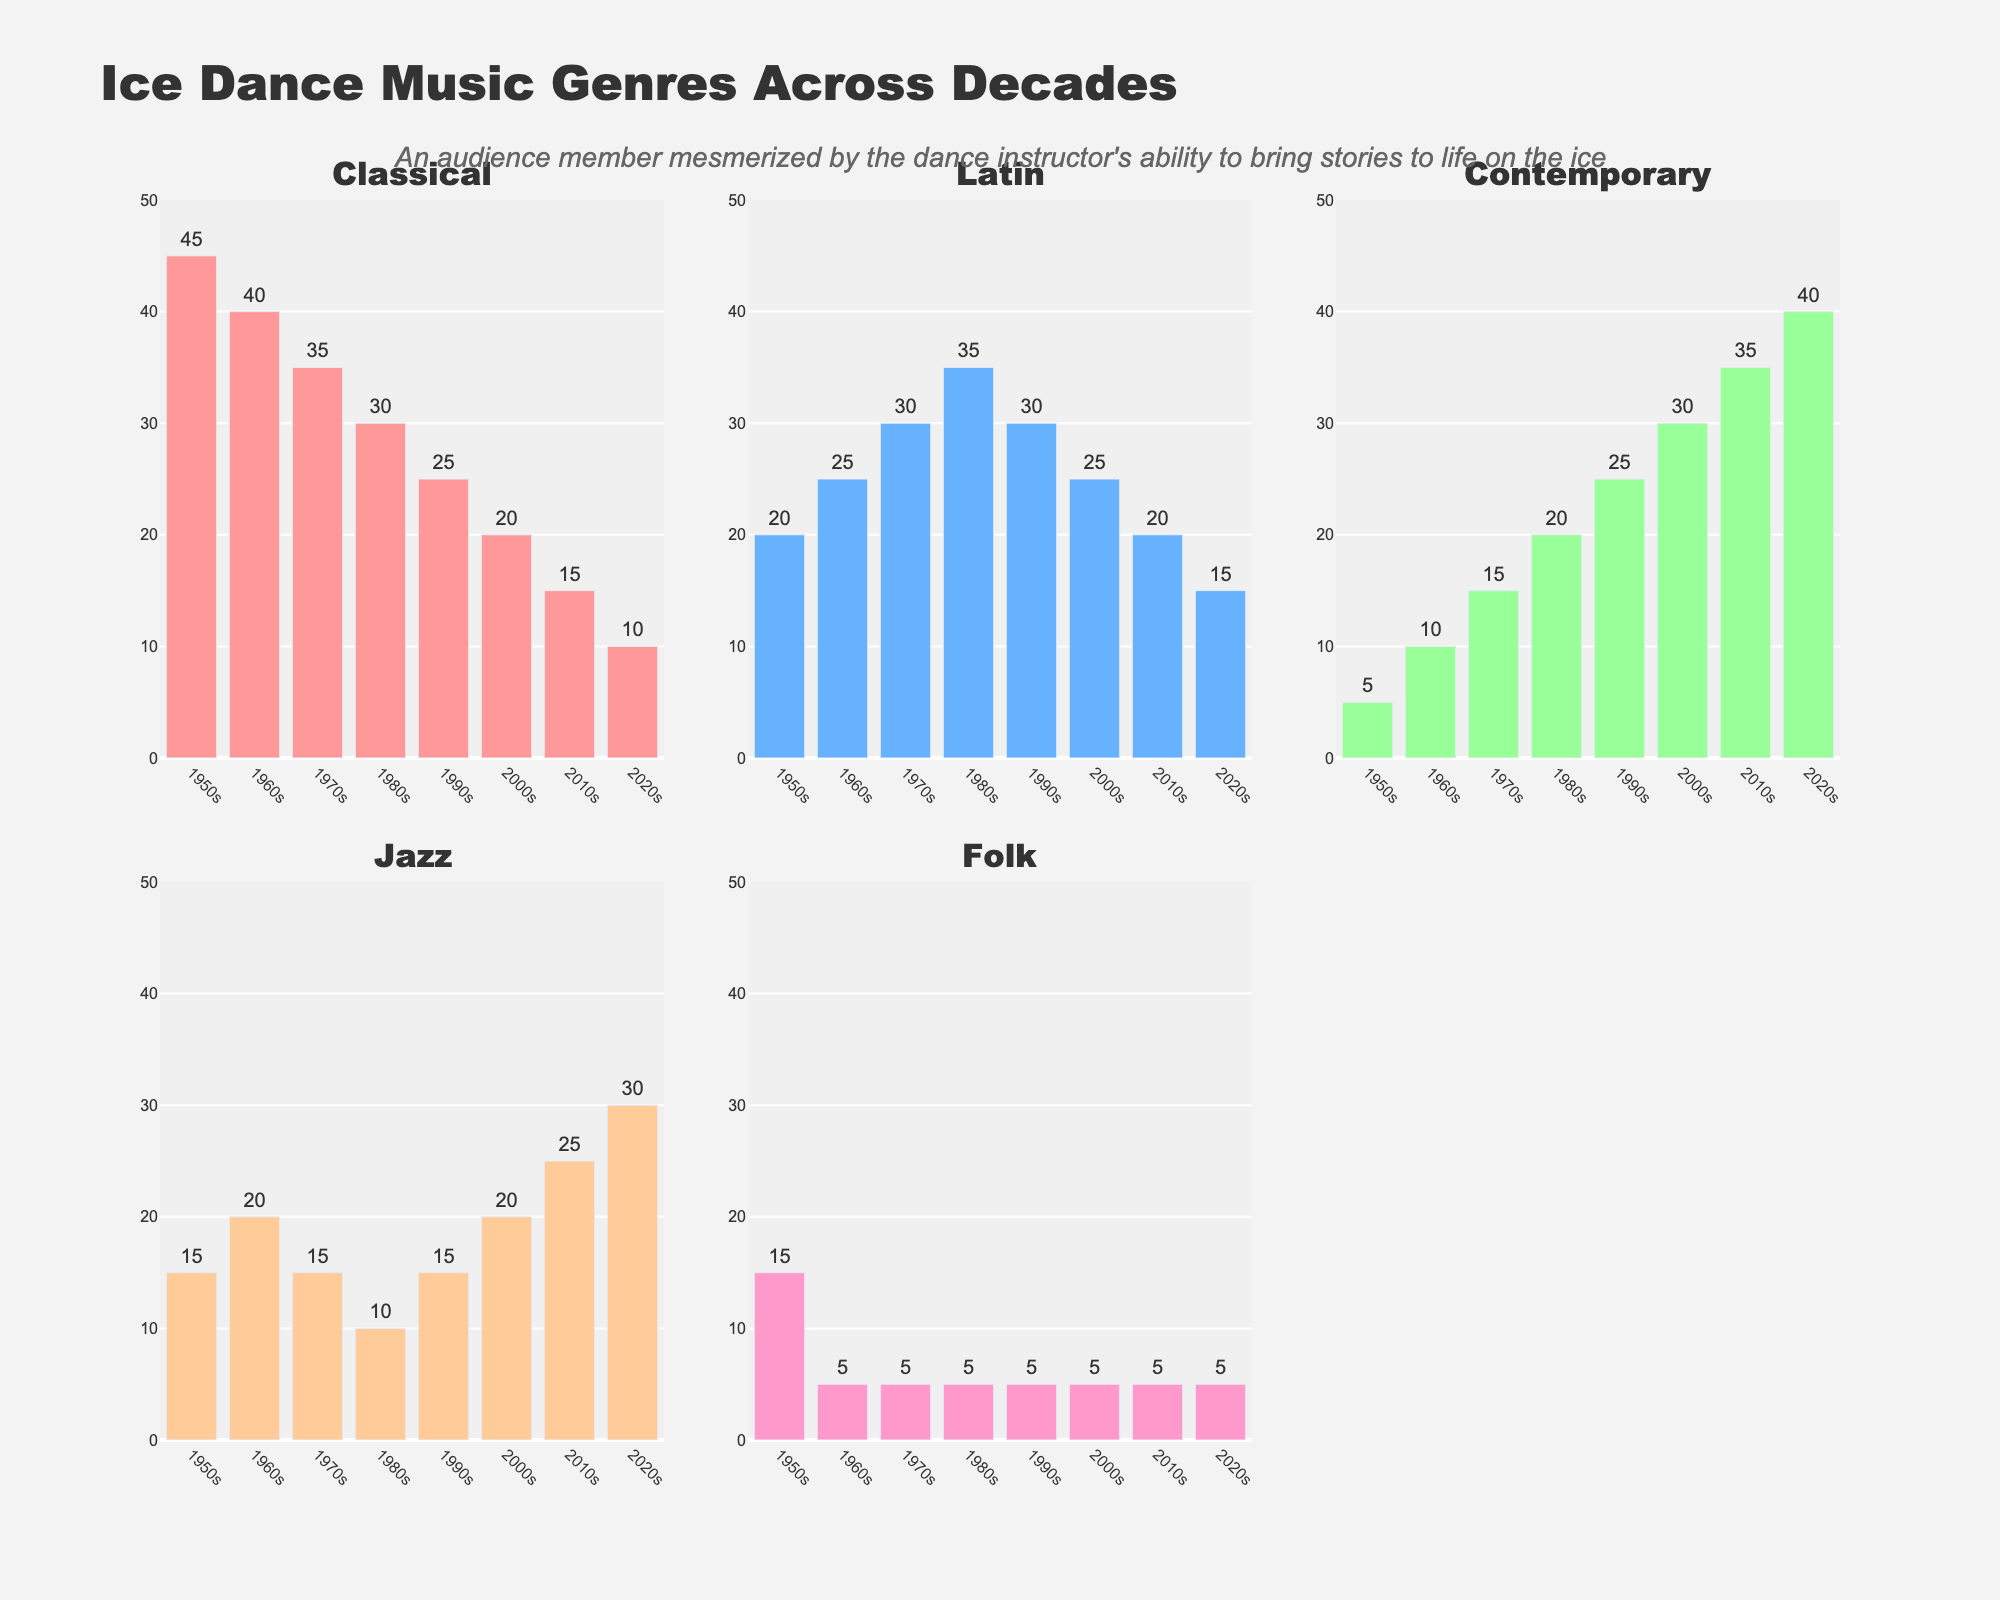What is the completion rate for the Legal department? Look at the bar chart in the upper subplot, find the Legal department, and refer to the value on the horizontal axis or the percentage text outside the bar.
Answer: 98% What is the range of completion rates shown in the box plot? Observe the spread of points and whiskers in the lower box plot to identify the minimum and maximum completion rates.
Answer: 76% to 100% Which department has the lowest completion rate? Look at the bar chart or the corresponding values on the vertical axis to find the department with the shortest bar.
Answer: Customer Service How many departments have a completion rate above 90%? Count the bars in the bar chart that have a completion rate greater than 90%.
Answer: Four What is the median completion rate in the box plot? Identify the central line within the box in the lower subplot, which represents the median.
Answer: 86.5% Compare the completion rate of the Finance and IT departments. Which one is higher? Find the bars for Finance and IT in the bar chart, then compare their lengths or the percentage labels outside the bars.
Answer: Finance How much higher is the completion rate for the Executive Team compared to Sales? Identify the completion rates for both departments from the bar chart and subtract the Sales rate from the Executive Team rate.
Answer: 22% What can you infer about the distribution of completion rates from the box plot? Observe the spread of points, whiskers, and the interquartile range in the lower subplot to describe the distribution, noting any outliers, equal spread, or clustering.
Answer: The completion rates are generally high, with most values clustered around 85%, but with a wider spread from 76% to 100% What color scale is used for the bars in the bar chart? Look at the gradient color used in the bar chart, noting the general hue transition from lower to higher completion rates.
Answer: Viridis Which department has a higher completion rate: Operations or Research & Development? By how much? Find the bars for Operations and Research & Development in the bar chart, compare their lengths or percentage labels, and calculate the difference.
Answer: Research & Development by 12% 